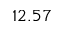Convert formula to latex. <formula><loc_0><loc_0><loc_500><loc_500>1 2 . 5 7</formula> 